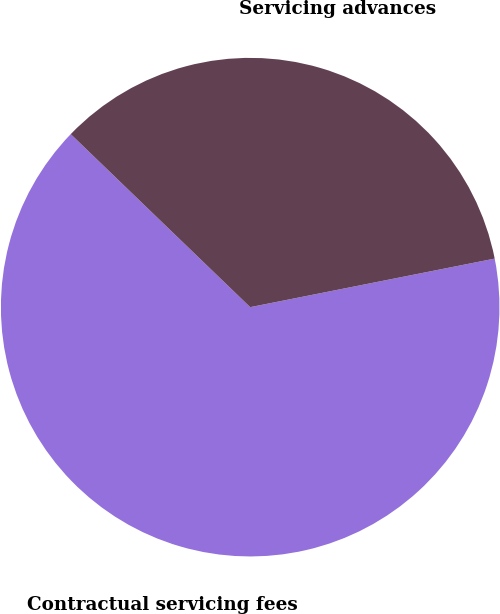Convert chart to OTSL. <chart><loc_0><loc_0><loc_500><loc_500><pie_chart><fcel>Contractual servicing fees<fcel>Servicing advances<nl><fcel>65.33%<fcel>34.67%<nl></chart> 